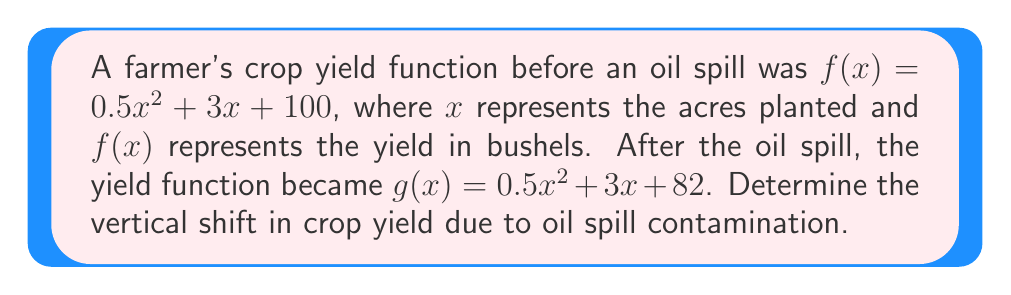Can you answer this question? To find the vertical shift between two functions, we need to compare their vertical intercepts or constant terms. In this case:

1) The original function: $f(x) = 0.5x^2 + 3x + 100$
2) The new function after the oil spill: $g(x) = 0.5x^2 + 3x + 82$

3) We can see that the quadratic term ($0.5x^2$) and the linear term ($3x$) remain the same in both functions. The only difference is in the constant term.

4) The vertical shift is the difference between these constant terms:
   $100 - 82 = 18$

5) Since the new function $g(x)$ has a smaller constant term, the graph has shifted downward.

Therefore, the vertical shift in crop yield due to oil spill contamination is 18 bushels downward.
Answer: 18 bushels downward 